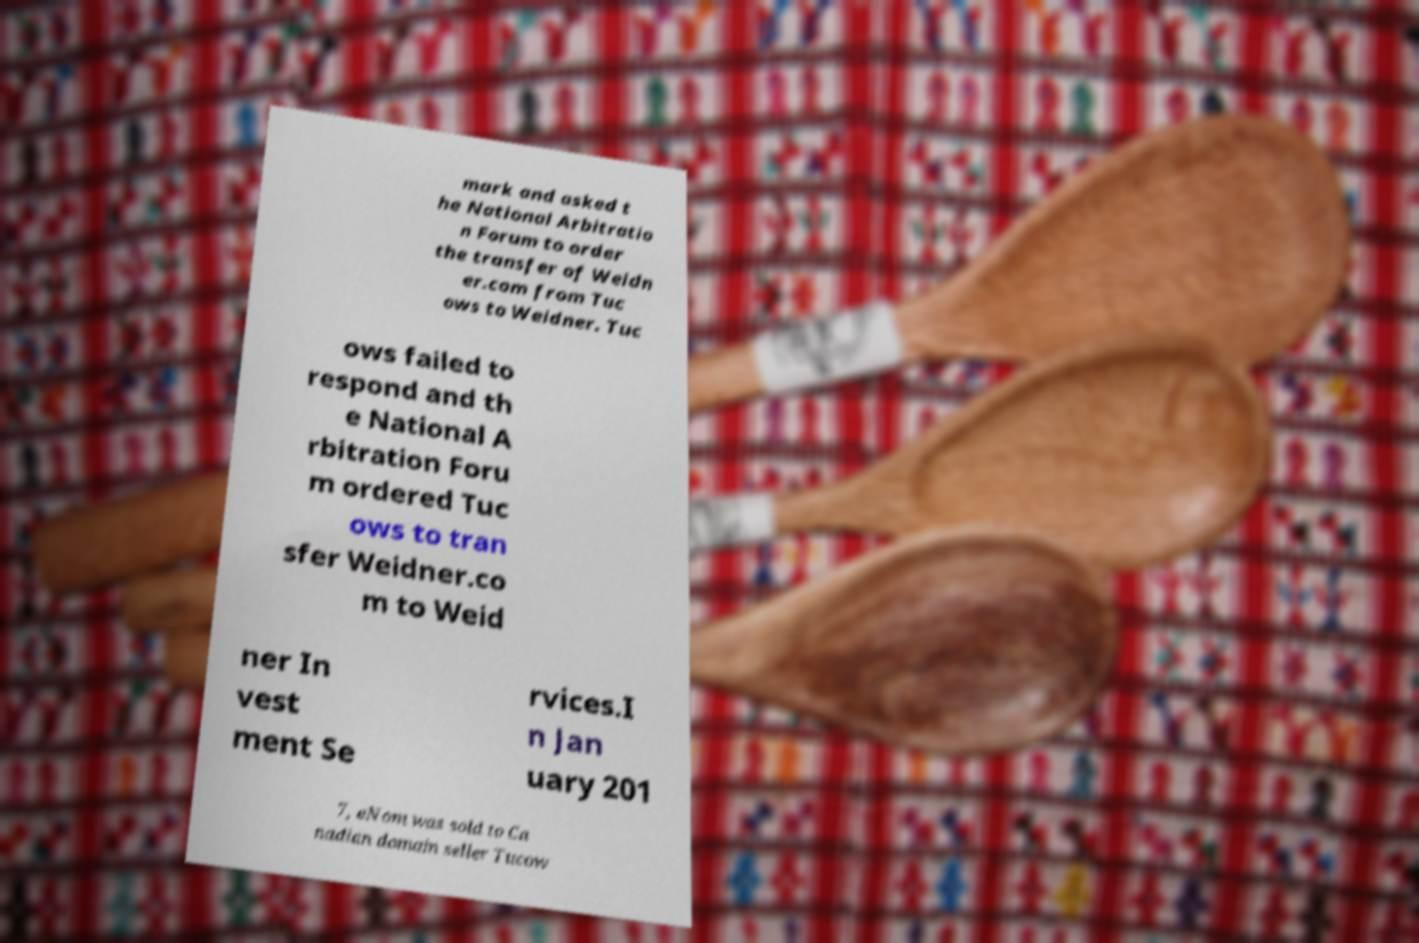Please identify and transcribe the text found in this image. mark and asked t he National Arbitratio n Forum to order the transfer of Weidn er.com from Tuc ows to Weidner. Tuc ows failed to respond and th e National A rbitration Foru m ordered Tuc ows to tran sfer Weidner.co m to Weid ner In vest ment Se rvices.I n Jan uary 201 7, eNom was sold to Ca nadian domain seller Tucow 